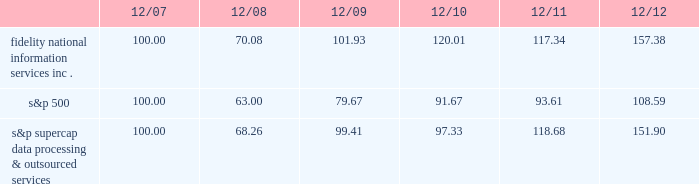
S&p supercap data processing & outsourced 100.00 68.26 99.41 97.33 118.68 151.90 item 6 .
Selected financial data .
The selected financial data set forth below constitutes historical financial data of fis and should be read in conjunction with item 7 , management 2019s discussion and analysis of financial condition and results of operations , and item 8 , financial statements and supplementary data , included elsewhere in this report .
On october 1 , 2009 , we completed the acquisition of metavante technologies , inc .
( "metavante" ) .
The results of operations and financial position of metavante are included in the consolidated financial statements since the date of acquisition .
On july 2 , 2008 , we completed the spin-off of lender processing services , inc. , which was a former wholly-owned subsidiary ( "lps" ) .
For accounting purposes , the results of lps are presented as discontinued operations .
Accordingly , all prior periods have been restated to present the results of fis on a stand alone basis and include the results of lps up to july 2 , 2008 , as discontinued operations. .
What is the roi of an investment in fidelity national information services from 2007 to 2008? 
Computations: ((70.08 - 100) / 100)
Answer: -0.2992. 